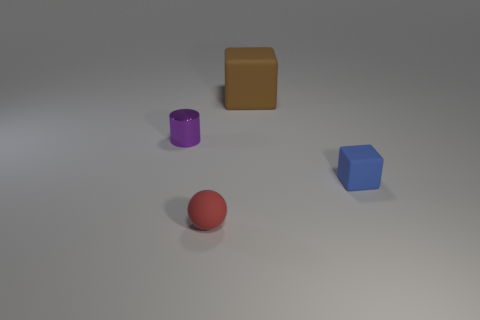Add 1 tiny purple cylinders. How many objects exist? 5 Subtract all cylinders. How many objects are left? 3 Subtract 0 yellow cubes. How many objects are left? 4 Subtract all small purple cylinders. Subtract all large purple cubes. How many objects are left? 3 Add 3 small purple metal things. How many small purple metal things are left? 4 Add 2 small blue blocks. How many small blue blocks exist? 3 